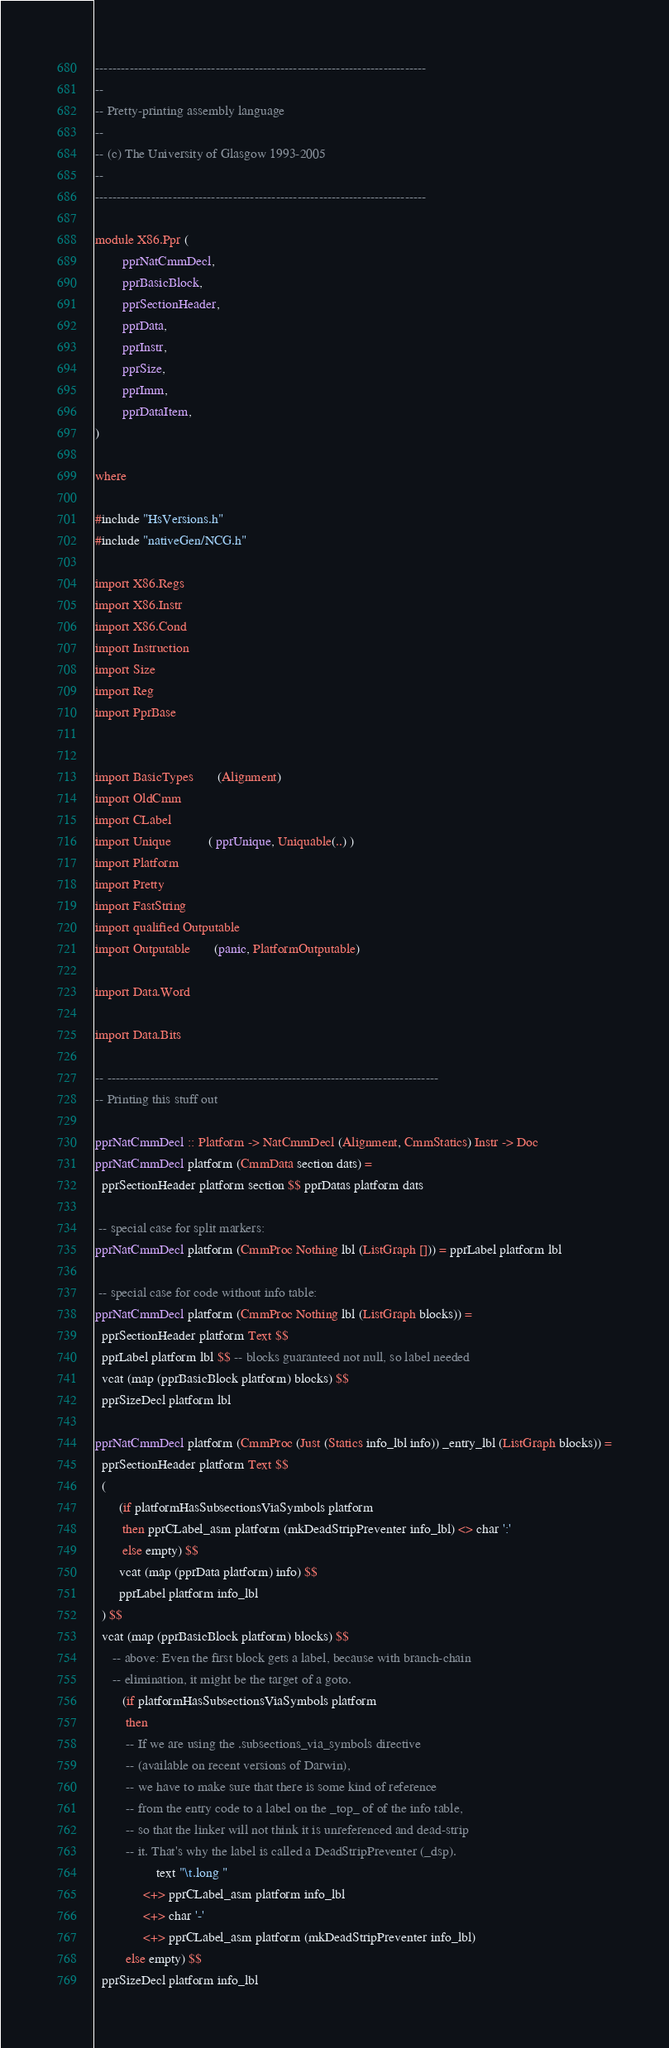<code> <loc_0><loc_0><loc_500><loc_500><_Haskell_>-----------------------------------------------------------------------------
--
-- Pretty-printing assembly language
--
-- (c) The University of Glasgow 1993-2005
--
-----------------------------------------------------------------------------

module X86.Ppr (
        pprNatCmmDecl,
        pprBasicBlock,
        pprSectionHeader,
        pprData,
        pprInstr,
        pprSize,
        pprImm,
        pprDataItem,
)

where

#include "HsVersions.h"
#include "nativeGen/NCG.h"

import X86.Regs
import X86.Instr
import X86.Cond
import Instruction
import Size
import Reg
import PprBase


import BasicTypes       (Alignment)
import OldCmm
import CLabel
import Unique           ( pprUnique, Uniquable(..) )
import Platform
import Pretty
import FastString
import qualified Outputable
import Outputable       (panic, PlatformOutputable)

import Data.Word

import Data.Bits

-- -----------------------------------------------------------------------------
-- Printing this stuff out

pprNatCmmDecl :: Platform -> NatCmmDecl (Alignment, CmmStatics) Instr -> Doc
pprNatCmmDecl platform (CmmData section dats) =
  pprSectionHeader platform section $$ pprDatas platform dats

 -- special case for split markers:
pprNatCmmDecl platform (CmmProc Nothing lbl (ListGraph [])) = pprLabel platform lbl

 -- special case for code without info table:
pprNatCmmDecl platform (CmmProc Nothing lbl (ListGraph blocks)) =
  pprSectionHeader platform Text $$
  pprLabel platform lbl $$ -- blocks guaranteed not null, so label needed
  vcat (map (pprBasicBlock platform) blocks) $$
  pprSizeDecl platform lbl

pprNatCmmDecl platform (CmmProc (Just (Statics info_lbl info)) _entry_lbl (ListGraph blocks)) =
  pprSectionHeader platform Text $$
  (
       (if platformHasSubsectionsViaSymbols platform
        then pprCLabel_asm platform (mkDeadStripPreventer info_lbl) <> char ':'
        else empty) $$
       vcat (map (pprData platform) info) $$
       pprLabel platform info_lbl
  ) $$
  vcat (map (pprBasicBlock platform) blocks) $$
     -- above: Even the first block gets a label, because with branch-chain
     -- elimination, it might be the target of a goto.
        (if platformHasSubsectionsViaSymbols platform
         then
         -- If we are using the .subsections_via_symbols directive
         -- (available on recent versions of Darwin),
         -- we have to make sure that there is some kind of reference
         -- from the entry code to a label on the _top_ of of the info table,
         -- so that the linker will not think it is unreferenced and dead-strip
         -- it. That's why the label is called a DeadStripPreventer (_dsp).
                  text "\t.long "
              <+> pprCLabel_asm platform info_lbl
              <+> char '-'
              <+> pprCLabel_asm platform (mkDeadStripPreventer info_lbl)
         else empty) $$
  pprSizeDecl platform info_lbl
</code> 